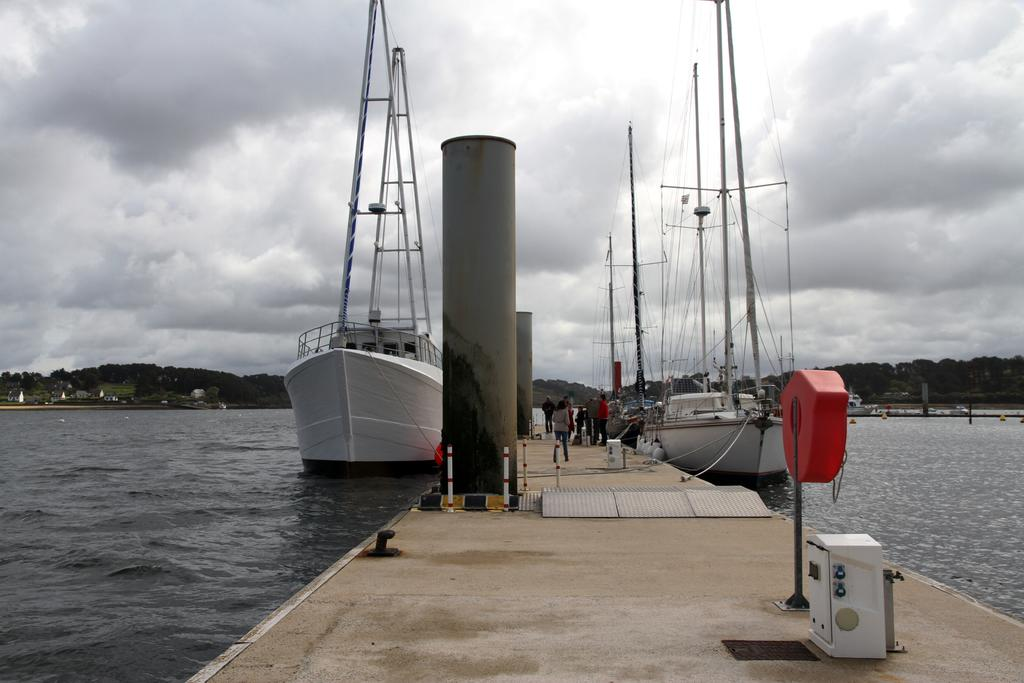What is the main feature in the center of the image? There is a boardwalk in the center of the image. What can be seen on the boardwalk? There are people on the boardwalk. What is visible on the water near the boardwalk? Ships are visible on the water. What type of landscape can be seen in the background of the image? There are hills in the background of the image. What is visible in the sky in the background of the image? The sky is visible in the background of the image. What type of flesh can be seen growing on the boardwalk in the image? There is no flesh visible on the boardwalk in the image; it is a wooden structure. 